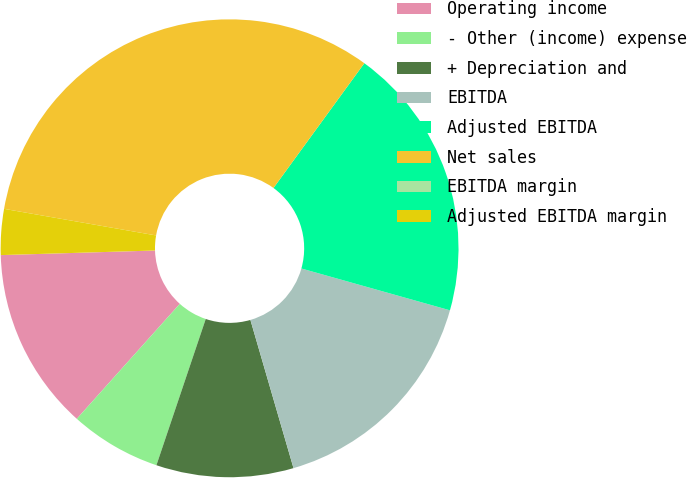Convert chart. <chart><loc_0><loc_0><loc_500><loc_500><pie_chart><fcel>Operating income<fcel>- Other (income) expense<fcel>+ Depreciation and<fcel>EBITDA<fcel>Adjusted EBITDA<fcel>Net sales<fcel>EBITDA margin<fcel>Adjusted EBITDA margin<nl><fcel>12.9%<fcel>6.45%<fcel>9.68%<fcel>16.13%<fcel>19.35%<fcel>32.26%<fcel>0.0%<fcel>3.23%<nl></chart> 